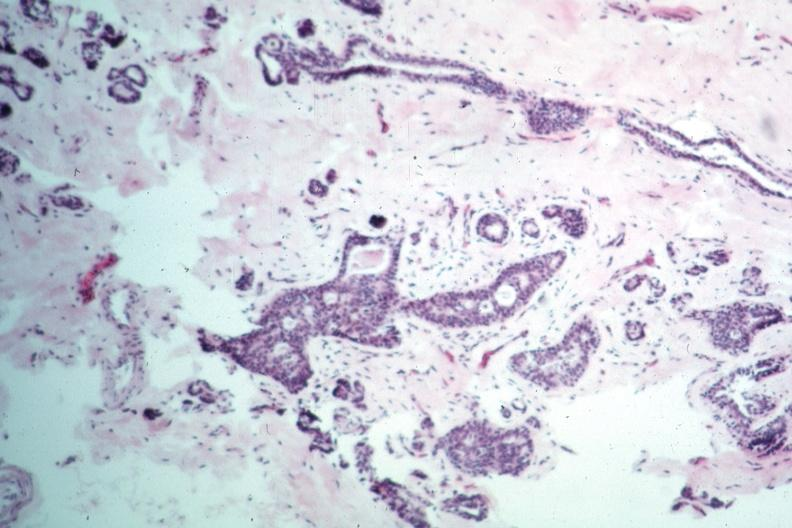how does this typical lesion appear?
Answer the question using a single word or phrase. Benign 